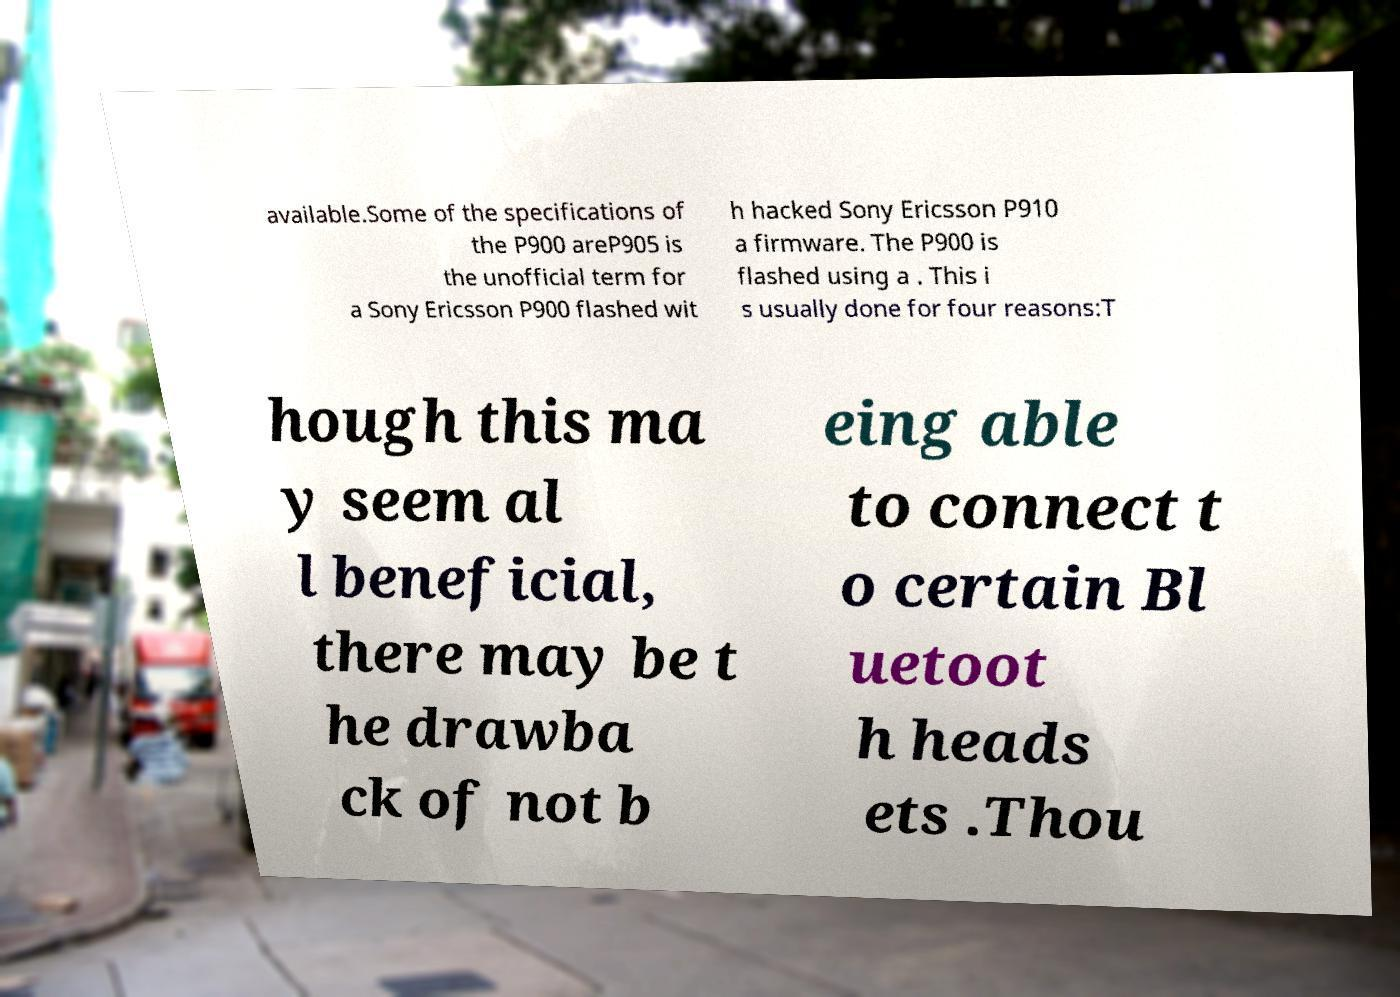Could you extract and type out the text from this image? available.Some of the specifications of the P900 areP905 is the unofficial term for a Sony Ericsson P900 flashed wit h hacked Sony Ericsson P910 a firmware. The P900 is flashed using a . This i s usually done for four reasons:T hough this ma y seem al l beneficial, there may be t he drawba ck of not b eing able to connect t o certain Bl uetoot h heads ets .Thou 